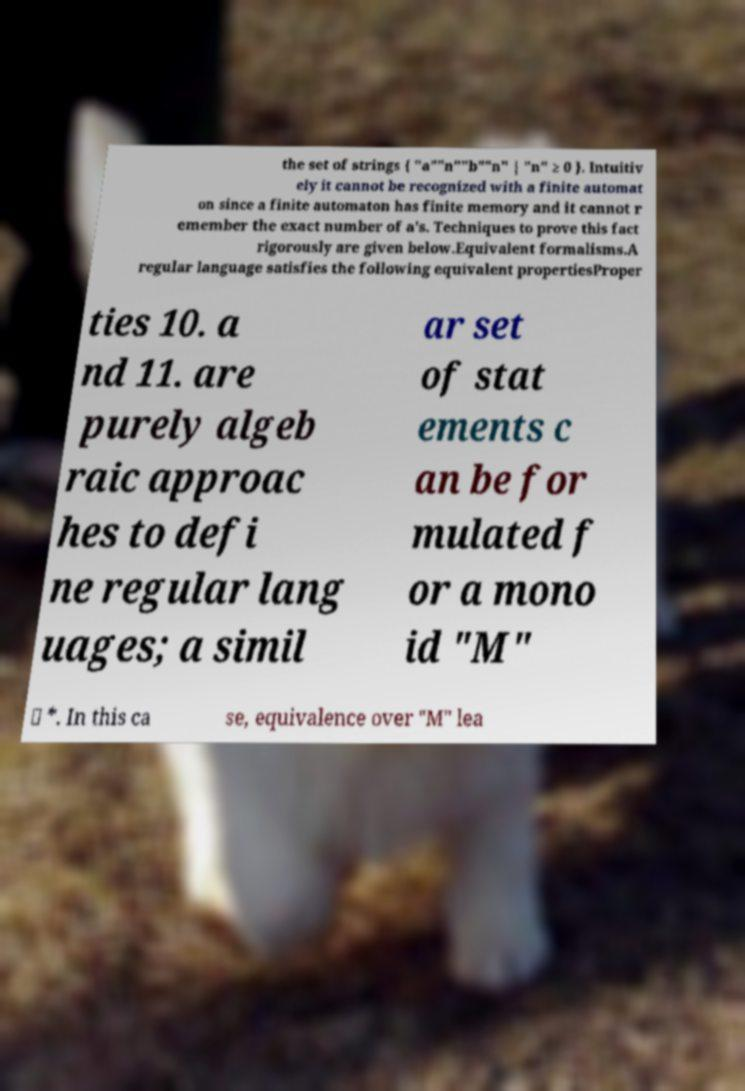Please identify and transcribe the text found in this image. the set of strings { "a""n""b""n" | "n" ≥ 0 }. Intuitiv ely it cannot be recognized with a finite automat on since a finite automaton has finite memory and it cannot r emember the exact number of a's. Techniques to prove this fact rigorously are given below.Equivalent formalisms.A regular language satisfies the following equivalent propertiesProper ties 10. a nd 11. are purely algeb raic approac hes to defi ne regular lang uages; a simil ar set of stat ements c an be for mulated f or a mono id "M" ⊆ *. In this ca se, equivalence over "M" lea 